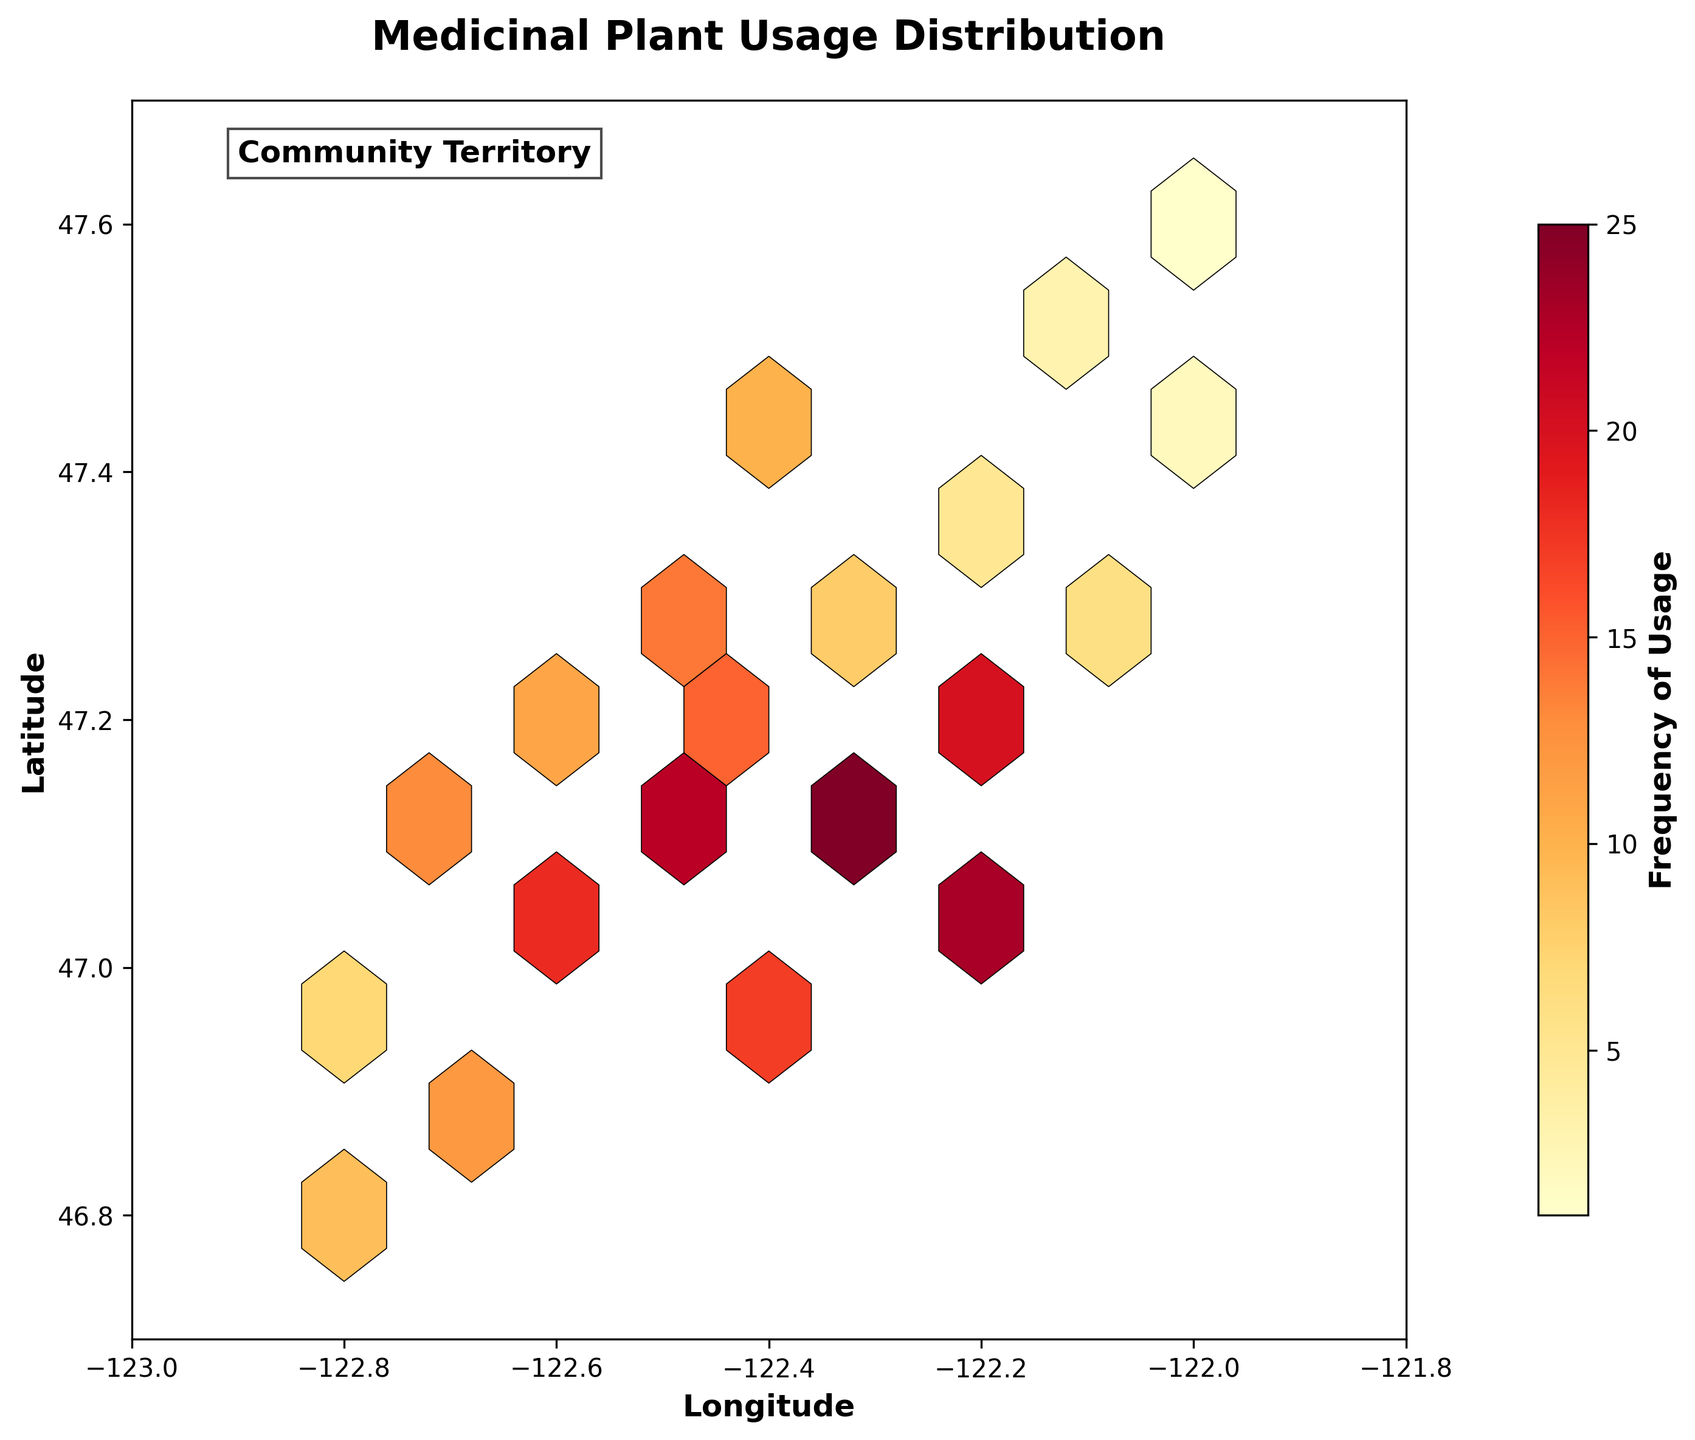What is the title of the plot? The title is the text displayed at the top center of the plot, describing what the plot represents. Here, the title is "Medicinal Plant Usage Distribution."
Answer: Medicinal Plant Usage Distribution What two aspects are represented on the axes of the plot? The x-axis represents the Longitude, and the y-axis represents the Latitude. These axes help to locate geographical points within the community's territory.
Answer: Longitude and Latitude What is the color label used and what does it represent? The color label is "Frequency of Usage," and it represents how often different geographical points within the territory use medicinal plants. The intensity of the color on the plot indicates higher or lower frequencies.
Answer: Frequency of Usage What is the color range used in the plot, and what does it signify? The color range used is from yellow to reddish-brown. Yellow areas indicate lower frequencies of medicinal plant usage, while reddish-brown areas indicate higher frequencies.
Answer: Yellow to reddish-brown At which coordinates is the text "Community Territory" placed in the plot? The text "Community Territory" is placed at the coordinates (-122.9, 47.65). This indicates a general area or context for the viewers.
Answer: (-122.9, 47.65) How many color bins suggest frequencies greater than 20? By observing the color scale, identify the color bins that correspond to frequencies greater than 20. These colors are darker shades of red. There are two such bins in the plot indicating higher frequencies.
Answer: 2 Which geographical point has the highest frequency of medicinal plant usage? The point with the highest frequency is marked by the darkest color on the plot. The geographical point (-122.3, 47.1) shows the highest frequency of 25.
Answer: (-122.3, 47.1) Compare the frequency of medicinal plant usage at the points (-122.5, 47.1) and (-122.2, 47.0). Which one is higher? Locate the points on the plot and compare their colors. The point (-122.5, 47.1) has a frequency of 22, while (-122.2, 47.0) has a frequency of 23. Thus, (-122.2, 47.0) is slightly higher.
Answer: (-122.2, 47.0) What is the average frequency of medicinal plant usage for coordinates (x: -122.2, -122.1, -122.0) and (y: 47.4)? Identify the coordinate points and their frequencies: (-122.2, 47.4) -> 5, (-122.1, 47.5) -> 3, (-122.0, 47.6) -> 1. Calculate the average: (5 + 3 + 1) / 3 = 3.
Answer: 3 What is the frequency difference between points (-122.4, 47.4) and (-122.4, 47.2)? Check the plot for frequencies at these points: (-122.4, 47.4) -> 10 and (-122.4, 47.2) -> 15. Calculate the difference: 15 - 10 = 5.
Answer: 5 